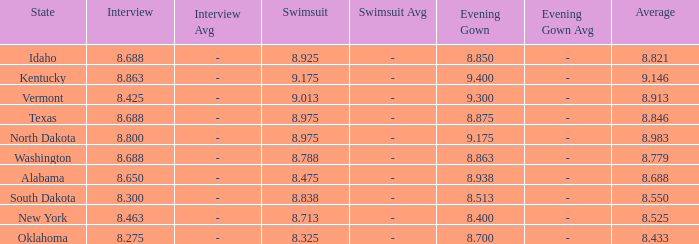What is the highest swimsuit score of the contestant with an evening gown larger than 9.175 and an interview score less than 8.425? None. 